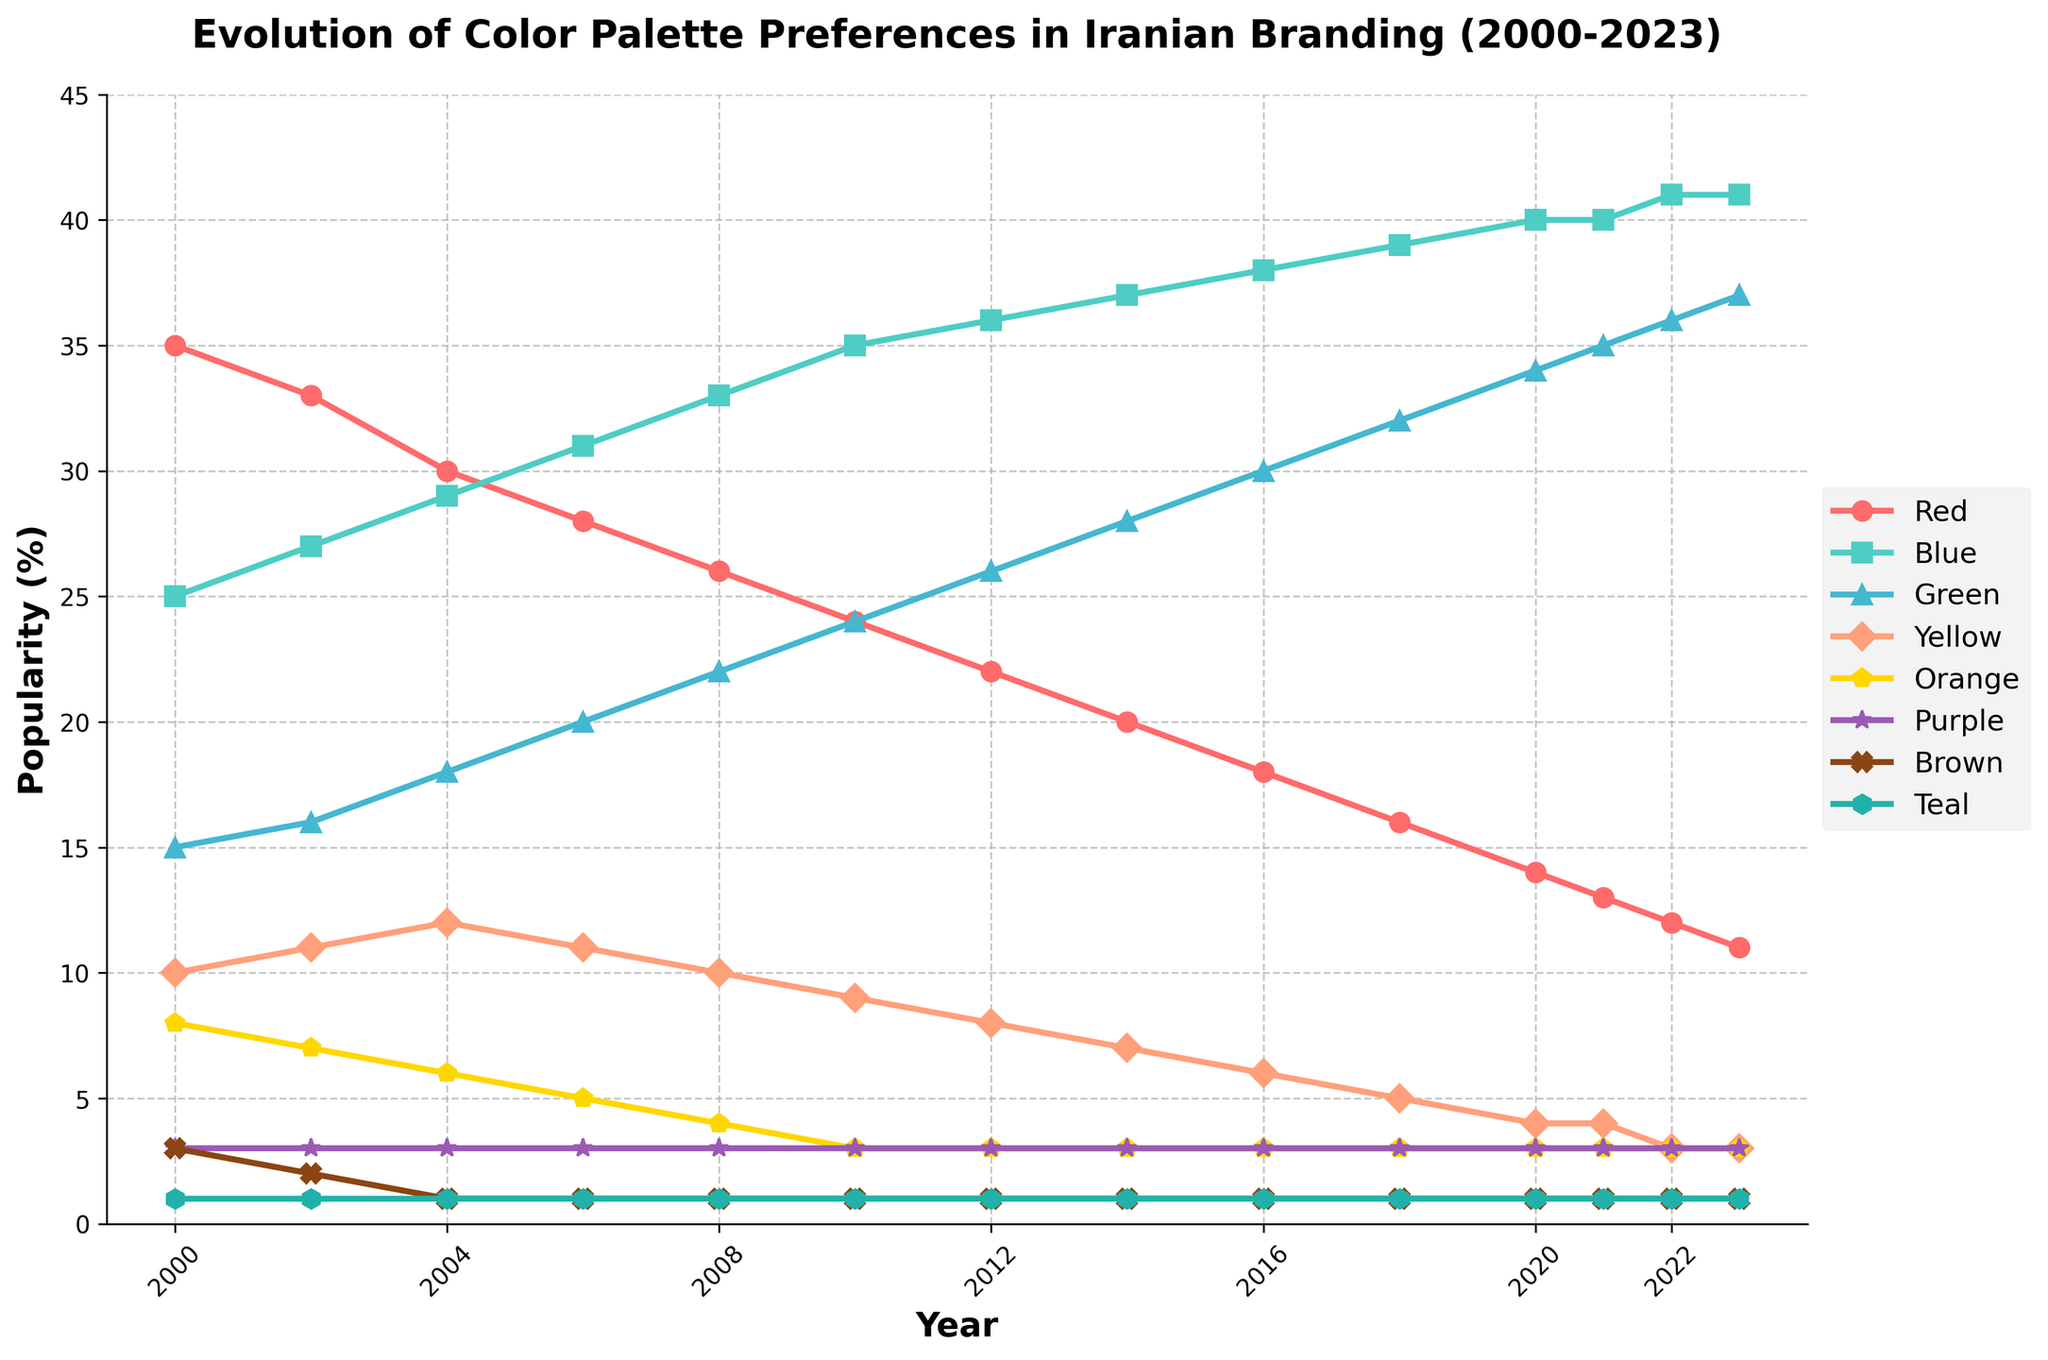Which color was the most popular in 2000? By looking at the heights of the lines in the year 2000, the red line is the highest indicating that red was the most popular.
Answer: Red How did the popularity of green change from 2000 to 2023? Observing the green line from 2000 to 2023, it shows a constant upward trend, starting from 15% in 2000 and reaching 37% in 2023.
Answer: Increased In 2023, which colors have equal popularity? Checking the values in 2023, Yellow, Orange, Purple, Brown, and Teal lines all end at the same height, indicating they have an equal popularity of 3%.
Answer: Yellow, Orange, Purple, Brown, and Teal What is the overall trend for the popularity of red between 2000 and 2023? The red line consistently declines from 35% in 2000 to 11% in 2023.
Answer: Declining Which color had the biggest increase in popularity between 2000 and 2023? The blue line exhibits the most significant increase, starting from 25% in 2000 and rising to 41% in 2023, an increase of 16%.
Answer: Blue Compare the popularity of yellow and teal in 2006. Which one is higher? Observing the chart in 2006, the yellow line is at 11%, and the teal line is at 1%. Therefore, yellow is higher.
Answer: Yellow If we sum the popularity percentages of all colors in 2000, what is the total? Adding the percentages for all colors in 2000: 35 + 25 + 15 + 10 + 8 + 3 + 3 + 1 equals 100%.
Answer: 100% Which two colors remained constant in popularity from 2000 to 2023? The brown and teal lines both remain flat throughout the period, each maintaining around 1%.
Answer: Brown and Teal What is the average popularity for blue in the years 2000, 2010, and 2020? Taking the values for blue in these years: (25 + 35 + 40) / 3 = 33.3%.
Answer: 33.3% Which year did blue first become the most popular color, surpassing red? By examining the intersecting point of the red and blue lines, blue first surpasses red in 2004.
Answer: 2004 